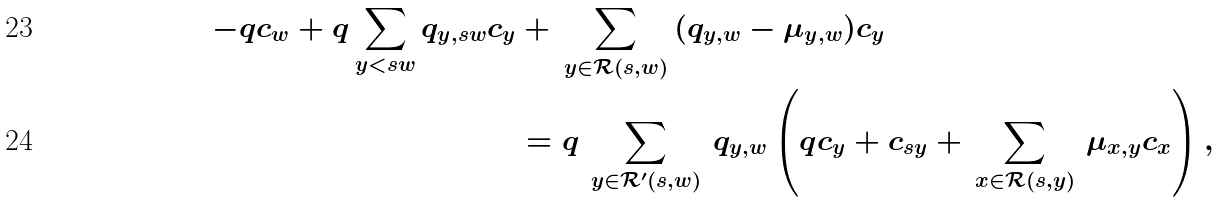Convert formula to latex. <formula><loc_0><loc_0><loc_500><loc_500>- q c _ { w } + q \sum _ { y < s w } q _ { y , s w } c _ { y } & + \, \sum _ { y \in \mathcal { R } ( s , w ) } \, ( q _ { y , w } - \mu _ { y , w } ) c _ { y } \\ & = q \, \sum _ { y \in \mathcal { R } ^ { \prime } ( s , w ) } \, q _ { y , w } \left ( q c _ { y } + c _ { s y } + \, \sum _ { x \in \mathcal { R } ( s , y ) } \, \mu _ { x , y } c _ { x } \right ) ,</formula> 